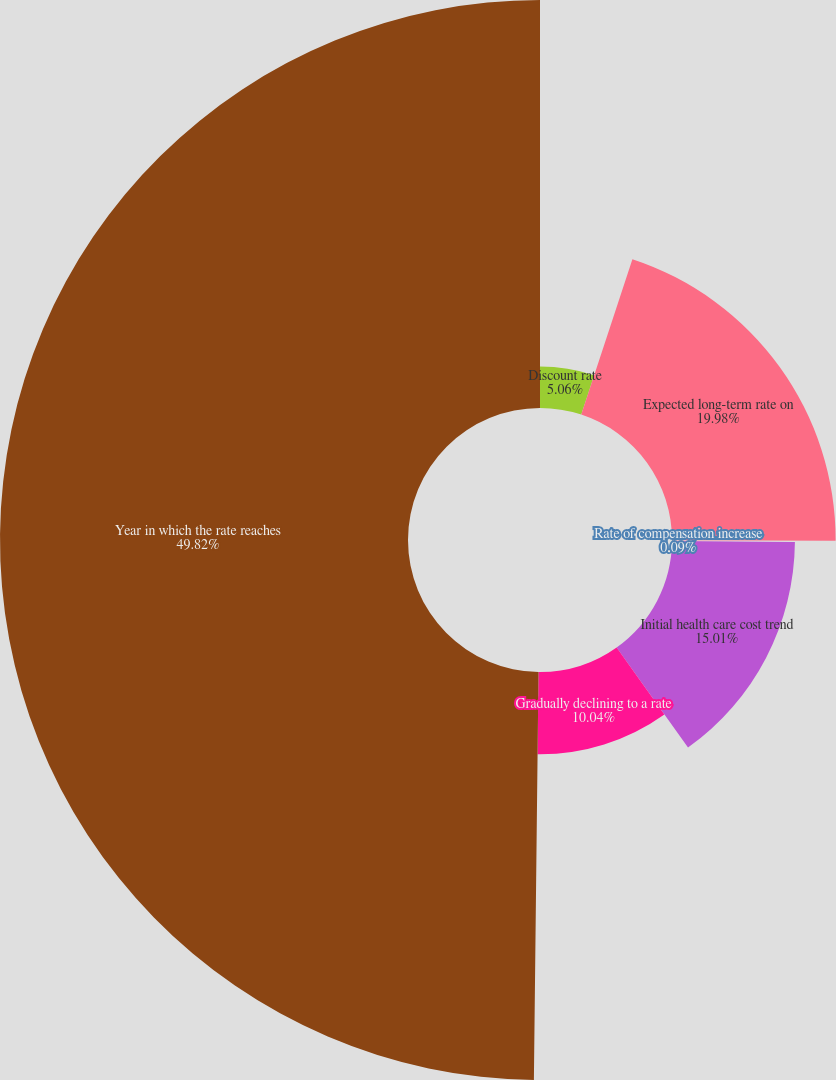Convert chart. <chart><loc_0><loc_0><loc_500><loc_500><pie_chart><fcel>Discount rate<fcel>Expected long-term rate on<fcel>Rate of compensation increase<fcel>Initial health care cost trend<fcel>Gradually declining to a rate<fcel>Year in which the rate reaches<nl><fcel>5.06%<fcel>19.98%<fcel>0.09%<fcel>15.01%<fcel>10.04%<fcel>49.82%<nl></chart> 